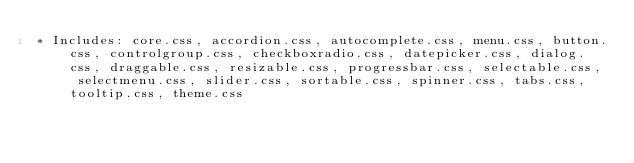Convert code to text. <code><loc_0><loc_0><loc_500><loc_500><_CSS_>* Includes: core.css, accordion.css, autocomplete.css, menu.css, button.css, controlgroup.css, checkboxradio.css, datepicker.css, dialog.css, draggable.css, resizable.css, progressbar.css, selectable.css, selectmenu.css, slider.css, sortable.css, spinner.css, tabs.css, tooltip.css, theme.css</code> 